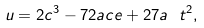Convert formula to latex. <formula><loc_0><loc_0><loc_500><loc_500>u = 2 c ^ { 3 } - 7 2 a c e + 2 7 a \ t ^ { 2 } ,</formula> 